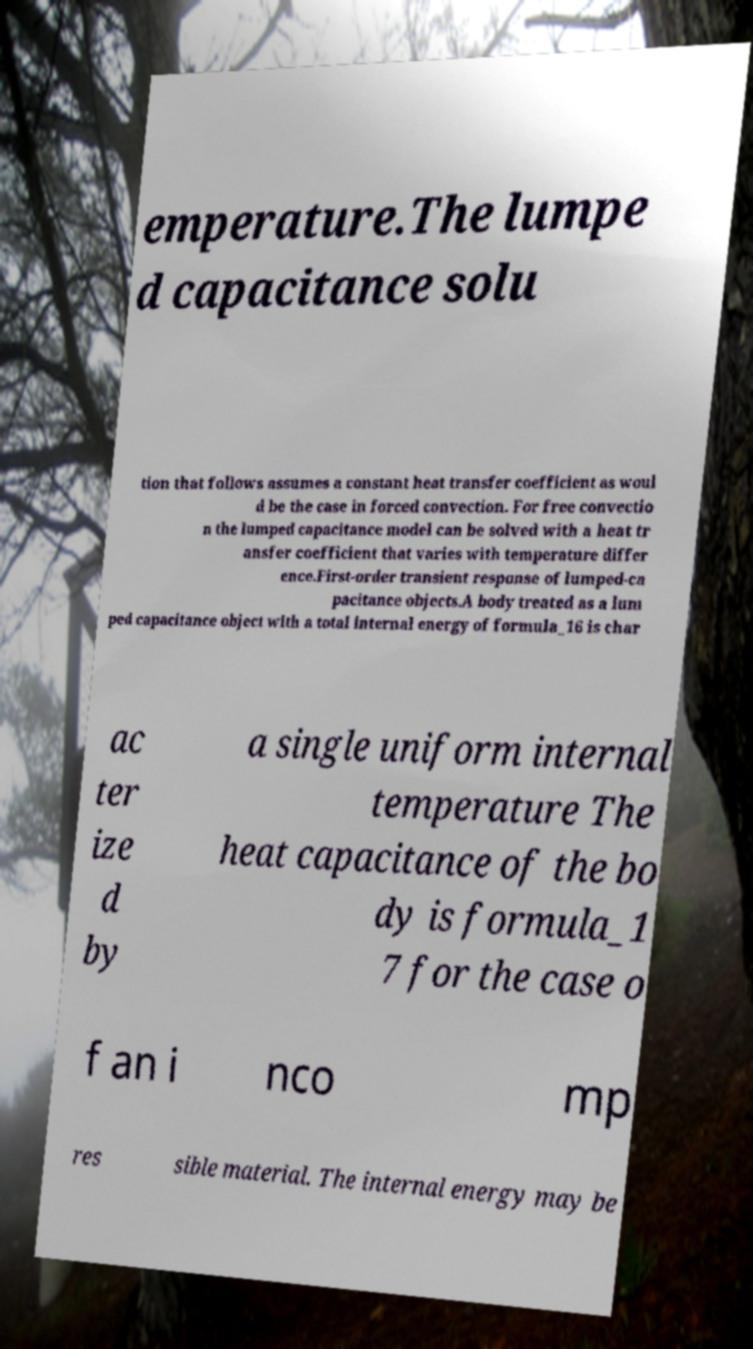I need the written content from this picture converted into text. Can you do that? emperature.The lumpe d capacitance solu tion that follows assumes a constant heat transfer coefficient as woul d be the case in forced convection. For free convectio n the lumped capacitance model can be solved with a heat tr ansfer coefficient that varies with temperature differ ence.First-order transient response of lumped-ca pacitance objects.A body treated as a lum ped capacitance object with a total internal energy of formula_16 is char ac ter ize d by a single uniform internal temperature The heat capacitance of the bo dy is formula_1 7 for the case o f an i nco mp res sible material. The internal energy may be 